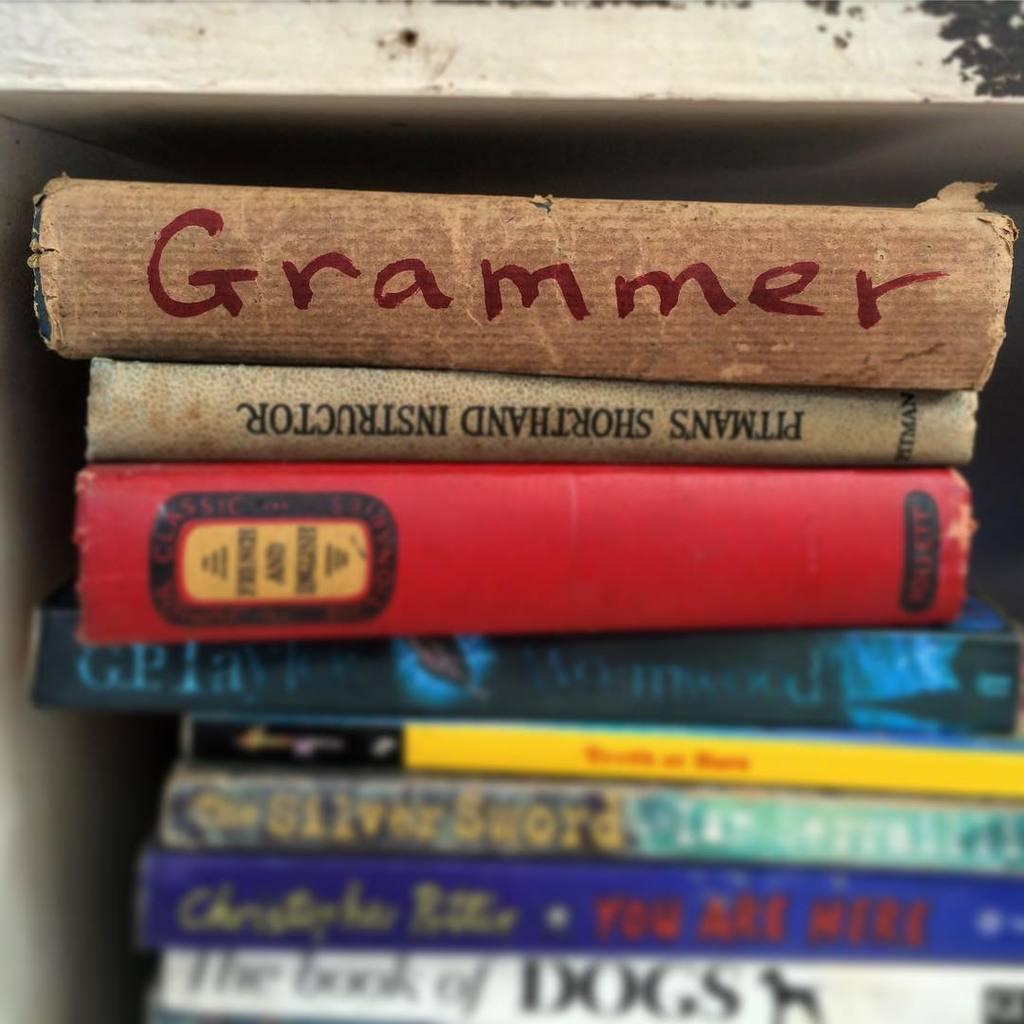<image>
Share a concise interpretation of the image provided. A book titled Grammer is on top of a stack of books. 